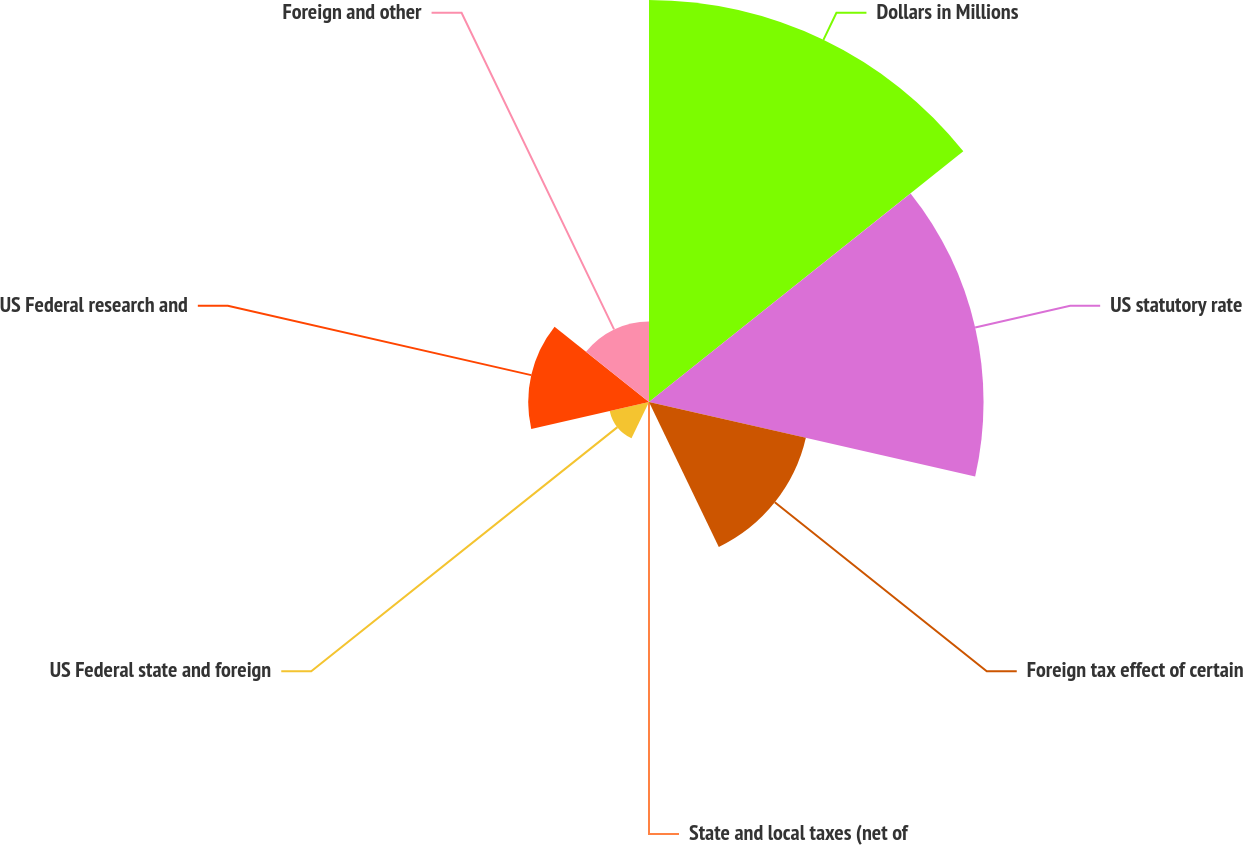Convert chart. <chart><loc_0><loc_0><loc_500><loc_500><pie_chart><fcel>Dollars in Millions<fcel>US statutory rate<fcel>Foreign tax effect of certain<fcel>State and local taxes (net of<fcel>US Federal state and foreign<fcel>US Federal research and<fcel>Foreign and other<nl><fcel>35.28%<fcel>29.36%<fcel>14.12%<fcel>0.02%<fcel>3.54%<fcel>10.6%<fcel>7.07%<nl></chart> 